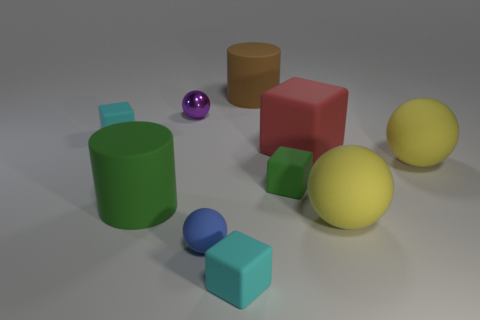Are there any cubes of the same color as the metallic object?
Ensure brevity in your answer.  No. Are the small purple sphere and the cyan cube in front of the big green thing made of the same material?
Your answer should be very brief. No. What number of big objects are yellow shiny cylinders or shiny spheres?
Ensure brevity in your answer.  0. Is the number of tiny green objects less than the number of gray objects?
Keep it short and to the point. No. There is a thing that is behind the tiny purple object; is it the same size as the green cylinder in front of the small purple object?
Give a very brief answer. Yes. What number of green objects are matte balls or tiny shiny objects?
Make the answer very short. 0. Is the number of big rubber things greater than the number of purple balls?
Give a very brief answer. Yes. Is the color of the small shiny sphere the same as the big matte cube?
Your answer should be compact. No. How many things are either tiny cyan matte objects or rubber cubes that are left of the purple metal object?
Your answer should be very brief. 2. How many other objects are there of the same shape as the tiny purple object?
Give a very brief answer. 3. 